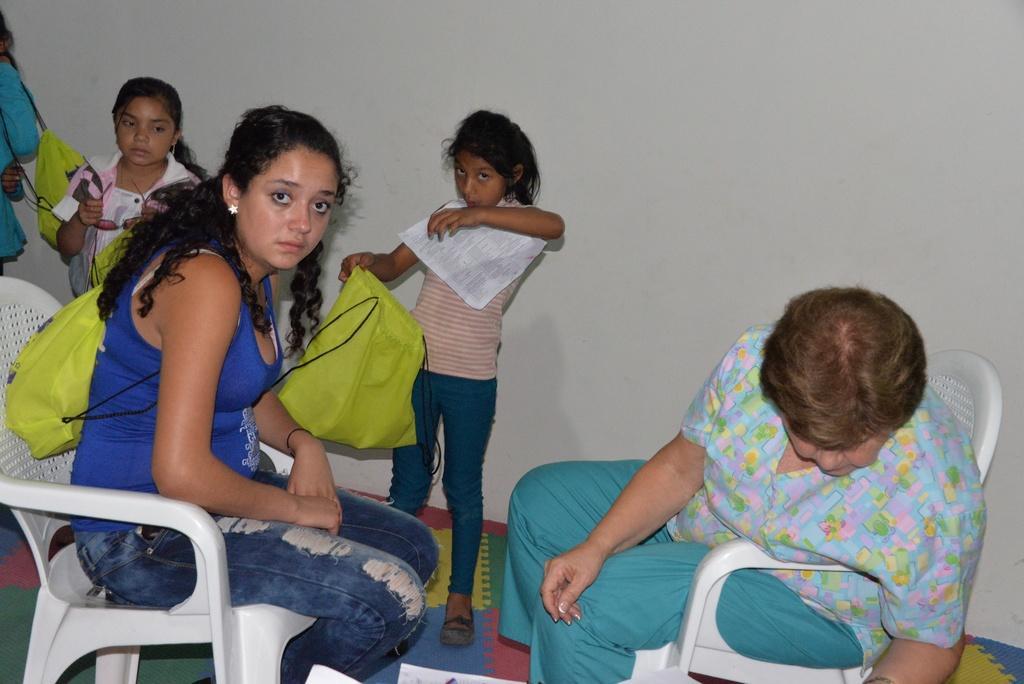In one or two sentences, can you explain what this image depicts? In this picture we can see two people sitting on chairs. In the background we can see a person, two girls, bags, paper, goggles and the wall. 